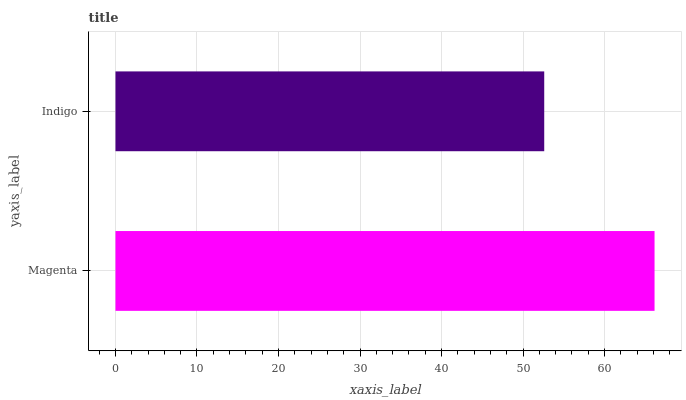Is Indigo the minimum?
Answer yes or no. Yes. Is Magenta the maximum?
Answer yes or no. Yes. Is Indigo the maximum?
Answer yes or no. No. Is Magenta greater than Indigo?
Answer yes or no. Yes. Is Indigo less than Magenta?
Answer yes or no. Yes. Is Indigo greater than Magenta?
Answer yes or no. No. Is Magenta less than Indigo?
Answer yes or no. No. Is Magenta the high median?
Answer yes or no. Yes. Is Indigo the low median?
Answer yes or no. Yes. Is Indigo the high median?
Answer yes or no. No. Is Magenta the low median?
Answer yes or no. No. 